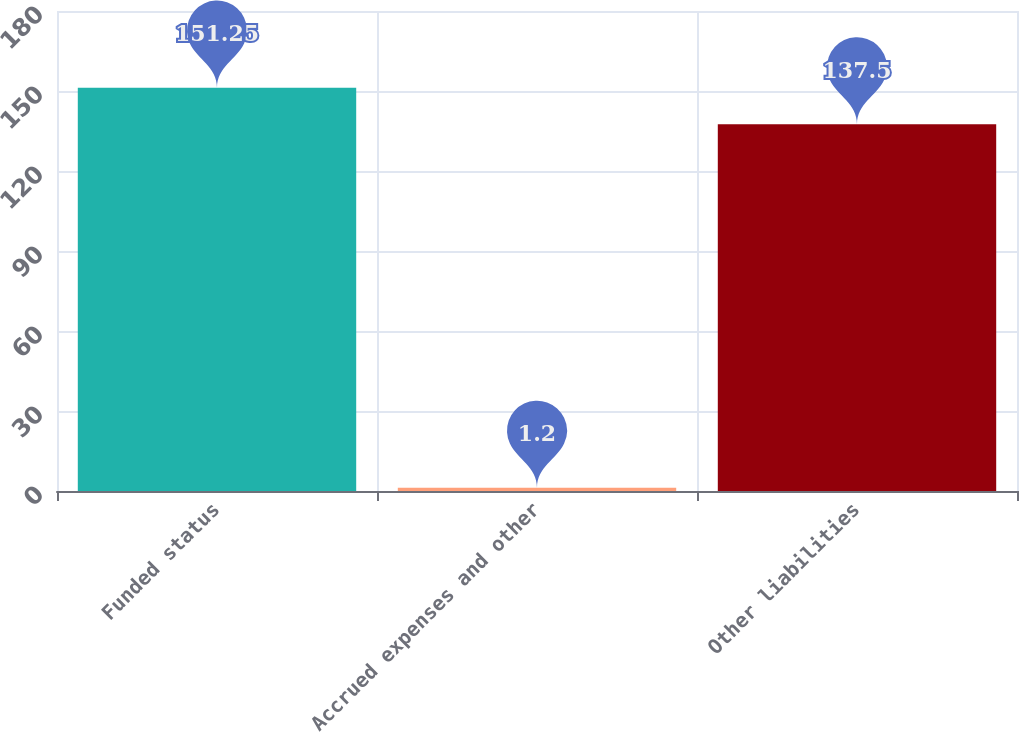Convert chart. <chart><loc_0><loc_0><loc_500><loc_500><bar_chart><fcel>Funded status<fcel>Accrued expenses and other<fcel>Other liabilities<nl><fcel>151.25<fcel>1.2<fcel>137.5<nl></chart> 